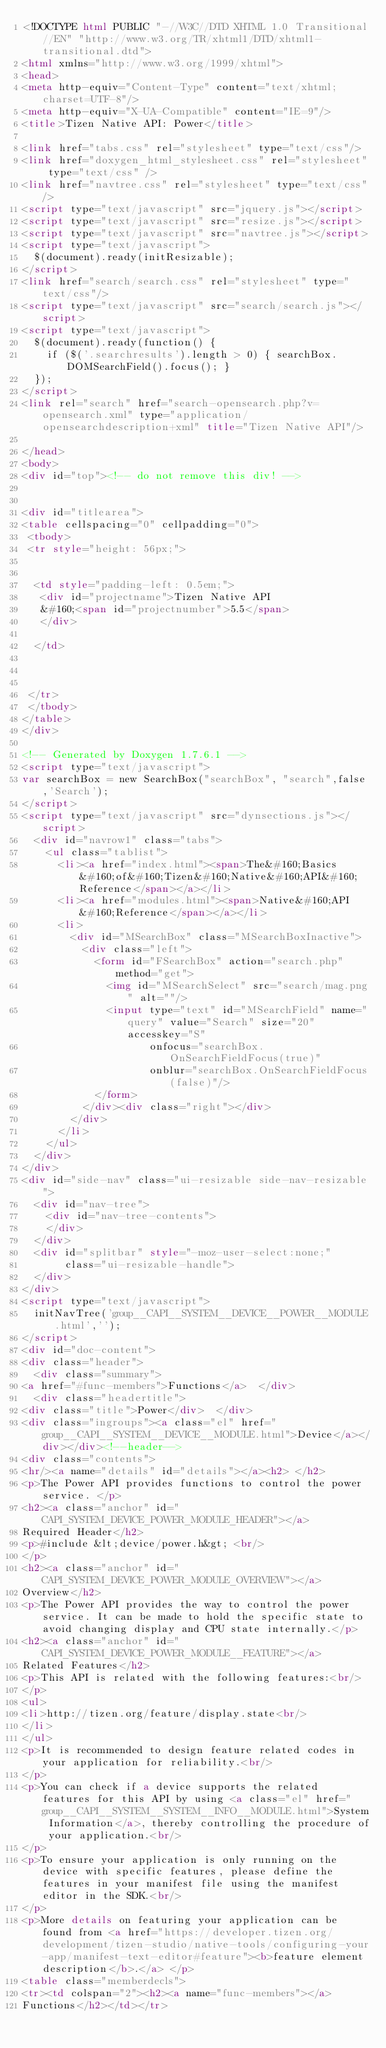<code> <loc_0><loc_0><loc_500><loc_500><_HTML_><!DOCTYPE html PUBLIC "-//W3C//DTD XHTML 1.0 Transitional//EN" "http://www.w3.org/TR/xhtml1/DTD/xhtml1-transitional.dtd">
<html xmlns="http://www.w3.org/1999/xhtml">
<head>
<meta http-equiv="Content-Type" content="text/xhtml;charset=UTF-8"/>
<meta http-equiv="X-UA-Compatible" content="IE=9"/>
<title>Tizen Native API: Power</title>

<link href="tabs.css" rel="stylesheet" type="text/css"/>
<link href="doxygen_html_stylesheet.css" rel="stylesheet" type="text/css" />
<link href="navtree.css" rel="stylesheet" type="text/css"/>
<script type="text/javascript" src="jquery.js"></script>
<script type="text/javascript" src="resize.js"></script>
<script type="text/javascript" src="navtree.js"></script>
<script type="text/javascript">
  $(document).ready(initResizable);
</script>
<link href="search/search.css" rel="stylesheet" type="text/css"/>
<script type="text/javascript" src="search/search.js"></script>
<script type="text/javascript">
  $(document).ready(function() {
    if ($('.searchresults').length > 0) { searchBox.DOMSearchField().focus(); }
  });
</script>
<link rel="search" href="search-opensearch.php?v=opensearch.xml" type="application/opensearchdescription+xml" title="Tizen Native API"/>

</head>
<body>
<div id="top"><!-- do not remove this div! -->


<div id="titlearea">
<table cellspacing="0" cellpadding="0">
 <tbody>
 <tr style="height: 56px;">
  
  
  <td style="padding-left: 0.5em;">
   <div id="projectname">Tizen Native API
   &#160;<span id="projectnumber">5.5</span>
   </div>
   
  </td>
  
  
  
 </tr>
 </tbody>
</table>
</div>

<!-- Generated by Doxygen 1.7.6.1 -->
<script type="text/javascript">
var searchBox = new SearchBox("searchBox", "search",false,'Search');
</script>
<script type="text/javascript" src="dynsections.js"></script>
  <div id="navrow1" class="tabs">
    <ul class="tablist">
      <li><a href="index.html"><span>The&#160;Basics&#160;of&#160;Tizen&#160;Native&#160;API&#160;Reference</span></a></li>
      <li><a href="modules.html"><span>Native&#160;API&#160;Reference</span></a></li>
      <li>
        <div id="MSearchBox" class="MSearchBoxInactive">
          <div class="left">
            <form id="FSearchBox" action="search.php" method="get">
              <img id="MSearchSelect" src="search/mag.png" alt=""/>
              <input type="text" id="MSearchField" name="query" value="Search" size="20" accesskey="S" 
                     onfocus="searchBox.OnSearchFieldFocus(true)" 
                     onblur="searchBox.OnSearchFieldFocus(false)"/>
            </form>
          </div><div class="right"></div>
        </div>
      </li>
    </ul>
  </div>
</div>
<div id="side-nav" class="ui-resizable side-nav-resizable">
  <div id="nav-tree">
    <div id="nav-tree-contents">
    </div>
  </div>
  <div id="splitbar" style="-moz-user-select:none;" 
       class="ui-resizable-handle">
  </div>
</div>
<script type="text/javascript">
  initNavTree('group__CAPI__SYSTEM__DEVICE__POWER__MODULE.html','');
</script>
<div id="doc-content">
<div class="header">
  <div class="summary">
<a href="#func-members">Functions</a>  </div>
  <div class="headertitle">
<div class="title">Power</div>  </div>
<div class="ingroups"><a class="el" href="group__CAPI__SYSTEM__DEVICE__MODULE.html">Device</a></div></div><!--header-->
<div class="contents">
<hr/><a name="details" id="details"></a><h2> </h2>
<p>The Power API provides functions to control the power service. </p>
<h2><a class="anchor" id="CAPI_SYSTEM_DEVICE_POWER_MODULE_HEADER"></a>
Required Header</h2>
<p>#include &lt;device/power.h&gt; <br/>
</p>
<h2><a class="anchor" id="CAPI_SYSTEM_DEVICE_POWER_MODULE_OVERVIEW"></a>
Overview</h2>
<p>The Power API provides the way to control the power service. It can be made to hold the specific state to avoid changing display and CPU state internally.</p>
<h2><a class="anchor" id="CAPI_SYSTEM_DEVICE_POWER_MODULE__FEATURE"></a>
Related Features</h2>
<p>This API is related with the following features:<br/>
</p>
<ul>
<li>http://tizen.org/feature/display.state<br/>
</li>
</ul>
<p>It is recommended to design feature related codes in your application for reliability.<br/>
</p>
<p>You can check if a device supports the related features for this API by using <a class="el" href="group__CAPI__SYSTEM__SYSTEM__INFO__MODULE.html">System Information</a>, thereby controlling the procedure of your application.<br/>
</p>
<p>To ensure your application is only running on the device with specific features, please define the features in your manifest file using the manifest editor in the SDK.<br/>
</p>
<p>More details on featuring your application can be found from <a href="https://developer.tizen.org/development/tizen-studio/native-tools/configuring-your-app/manifest-text-editor#feature"><b>feature element description</b>.</a> </p>
<table class="memberdecls">
<tr><td colspan="2"><h2><a name="func-members"></a>
Functions</h2></td></tr></code> 